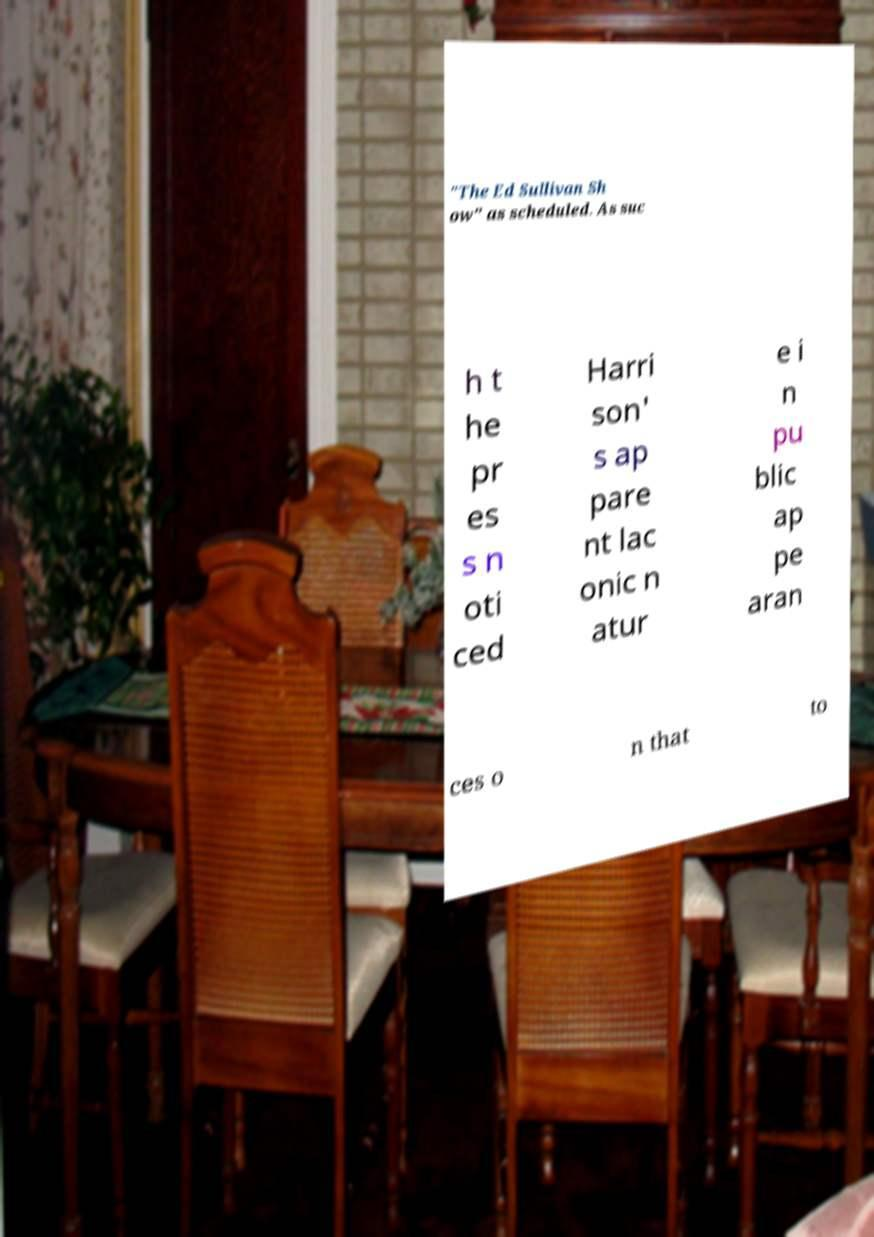Could you assist in decoding the text presented in this image and type it out clearly? "The Ed Sullivan Sh ow" as scheduled. As suc h t he pr es s n oti ced Harri son' s ap pare nt lac onic n atur e i n pu blic ap pe aran ces o n that to 